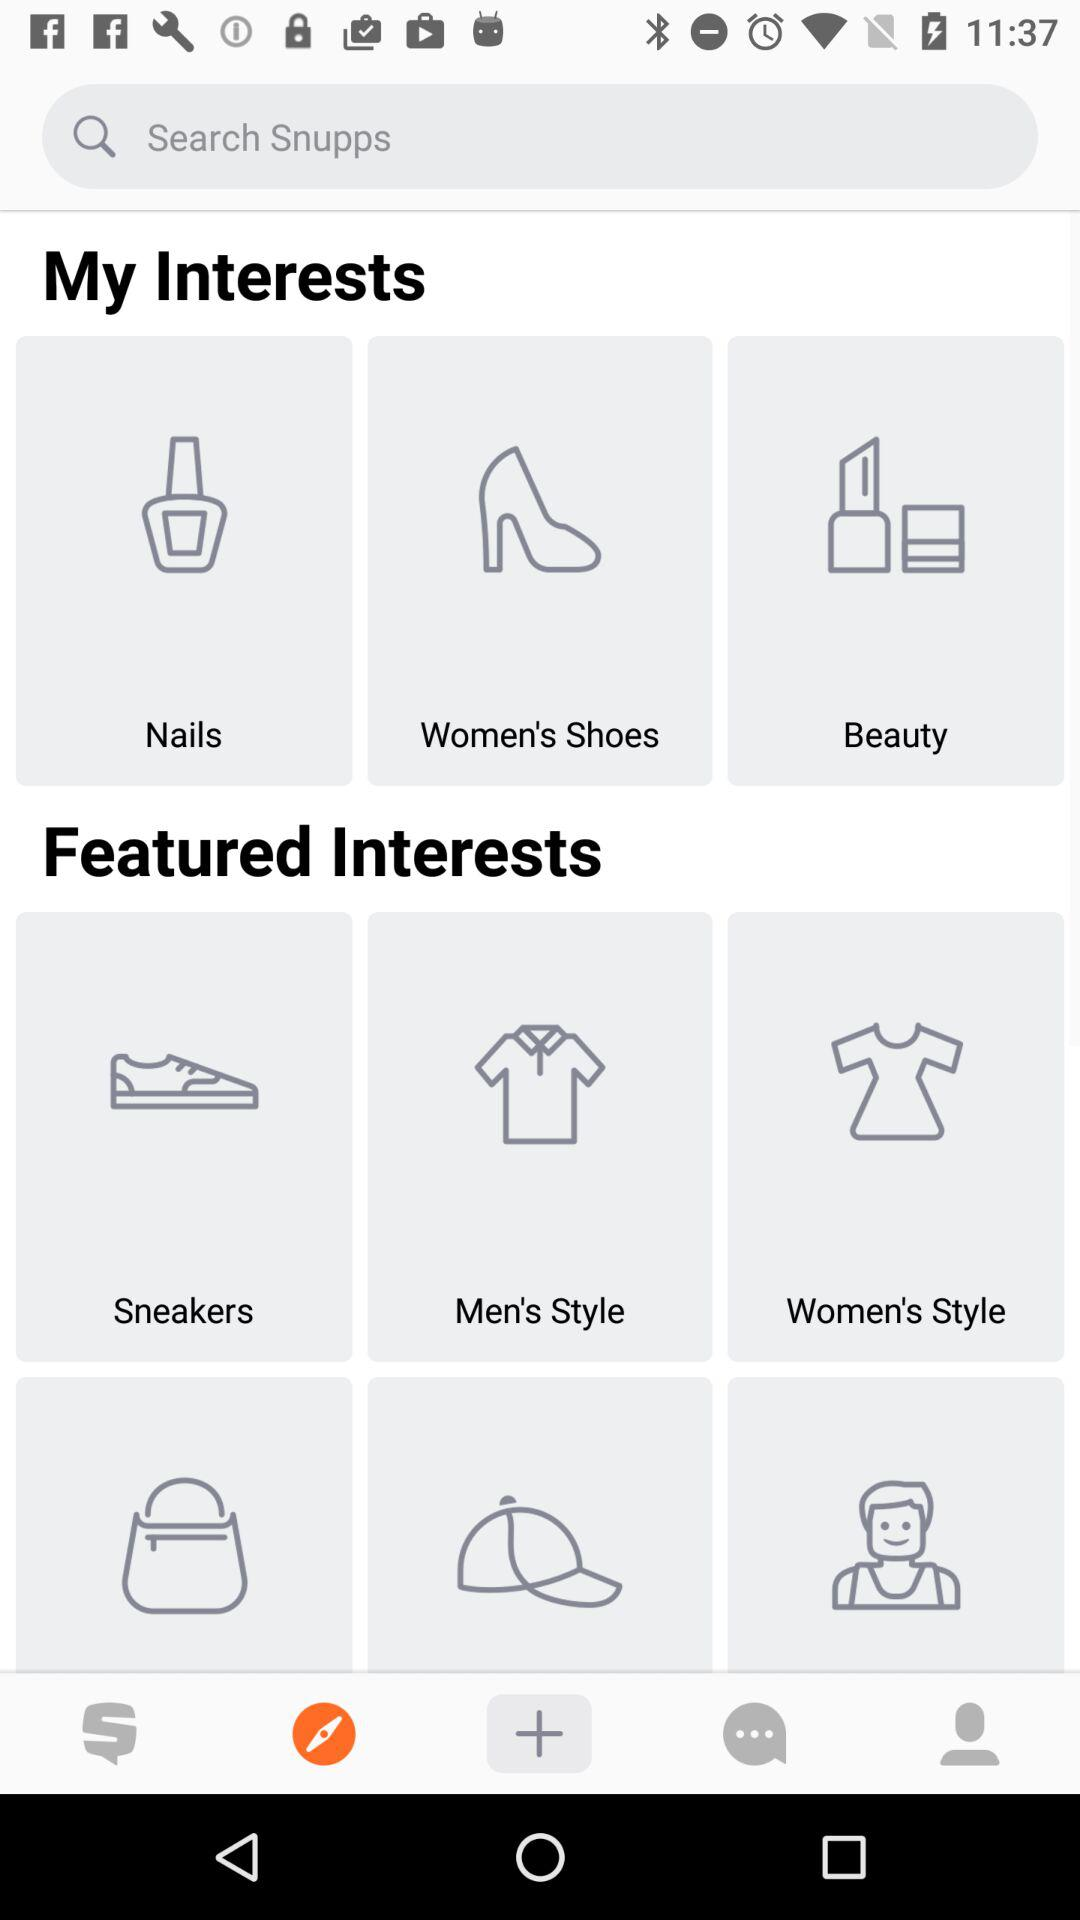What options are there in "My Interests"? The options in "My Interests" are "Nails", "Women's Shoes" and "Beauty". 